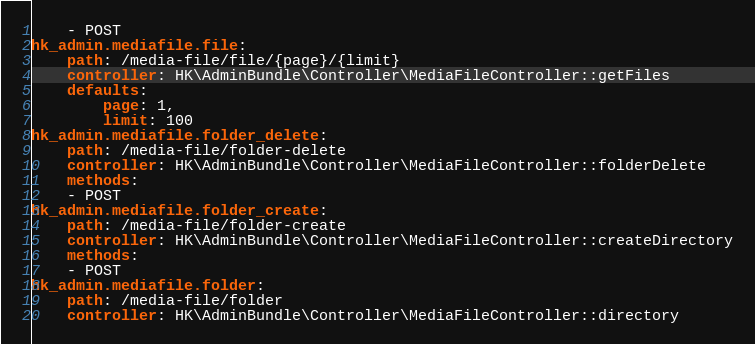<code> <loc_0><loc_0><loc_500><loc_500><_YAML_>    - POST
hk_admin.mediafile.file:
    path: /media-file/file/{page}/{limit}
    controller: HK\AdminBundle\Controller\MediaFileController::getFiles
    defaults:
        page: 1,
        limit: 100
hk_admin.mediafile.folder_delete:
    path: /media-file/folder-delete
    controller: HK\AdminBundle\Controller\MediaFileController::folderDelete
    methods:
    - POST
hk_admin.mediafile.folder_create:
    path: /media-file/folder-create
    controller: HK\AdminBundle\Controller\MediaFileController::createDirectory
    methods:
    - POST
hk_admin.mediafile.folder:
    path: /media-file/folder
    controller: HK\AdminBundle\Controller\MediaFileController::directory</code> 